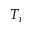<formula> <loc_0><loc_0><loc_500><loc_500>T _ { i }</formula> 